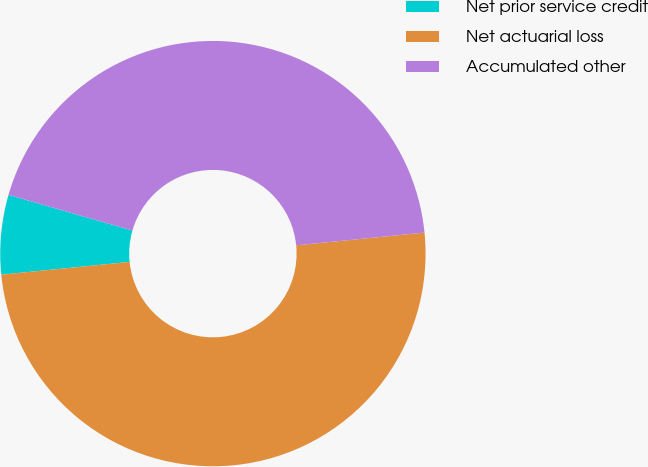Convert chart. <chart><loc_0><loc_0><loc_500><loc_500><pie_chart><fcel>Net prior service credit<fcel>Net actuarial loss<fcel>Accumulated other<nl><fcel>6.03%<fcel>50.0%<fcel>43.97%<nl></chart> 